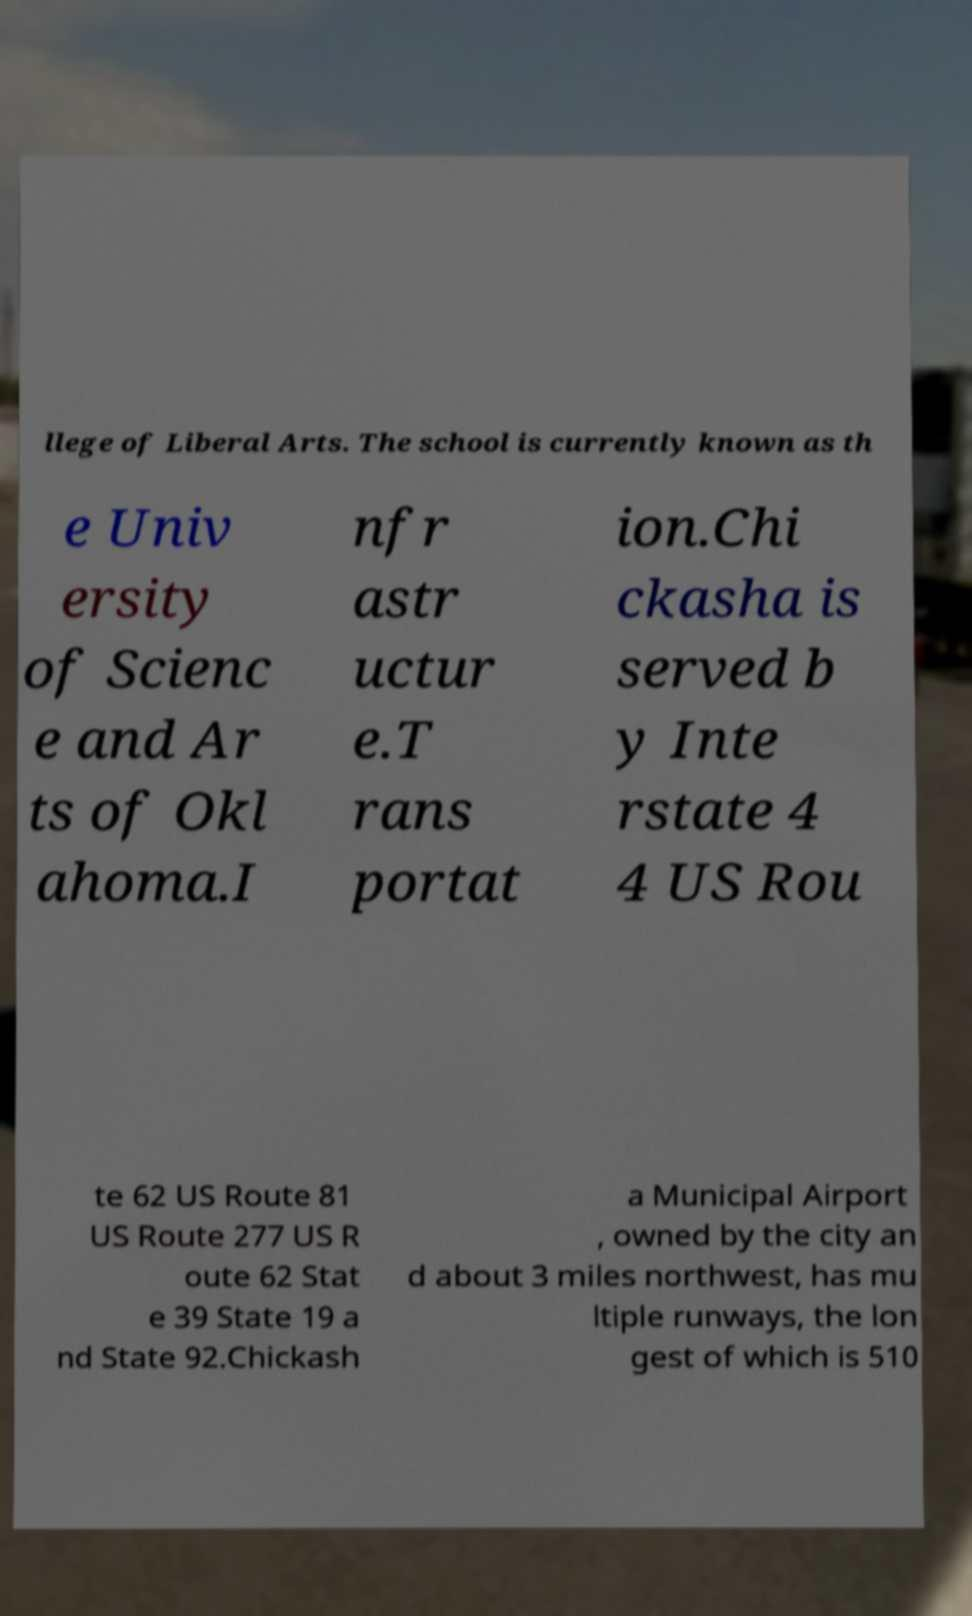Please identify and transcribe the text found in this image. llege of Liberal Arts. The school is currently known as th e Univ ersity of Scienc e and Ar ts of Okl ahoma.I nfr astr uctur e.T rans portat ion.Chi ckasha is served b y Inte rstate 4 4 US Rou te 62 US Route 81 US Route 277 US R oute 62 Stat e 39 State 19 a nd State 92.Chickash a Municipal Airport , owned by the city an d about 3 miles northwest, has mu ltiple runways, the lon gest of which is 510 